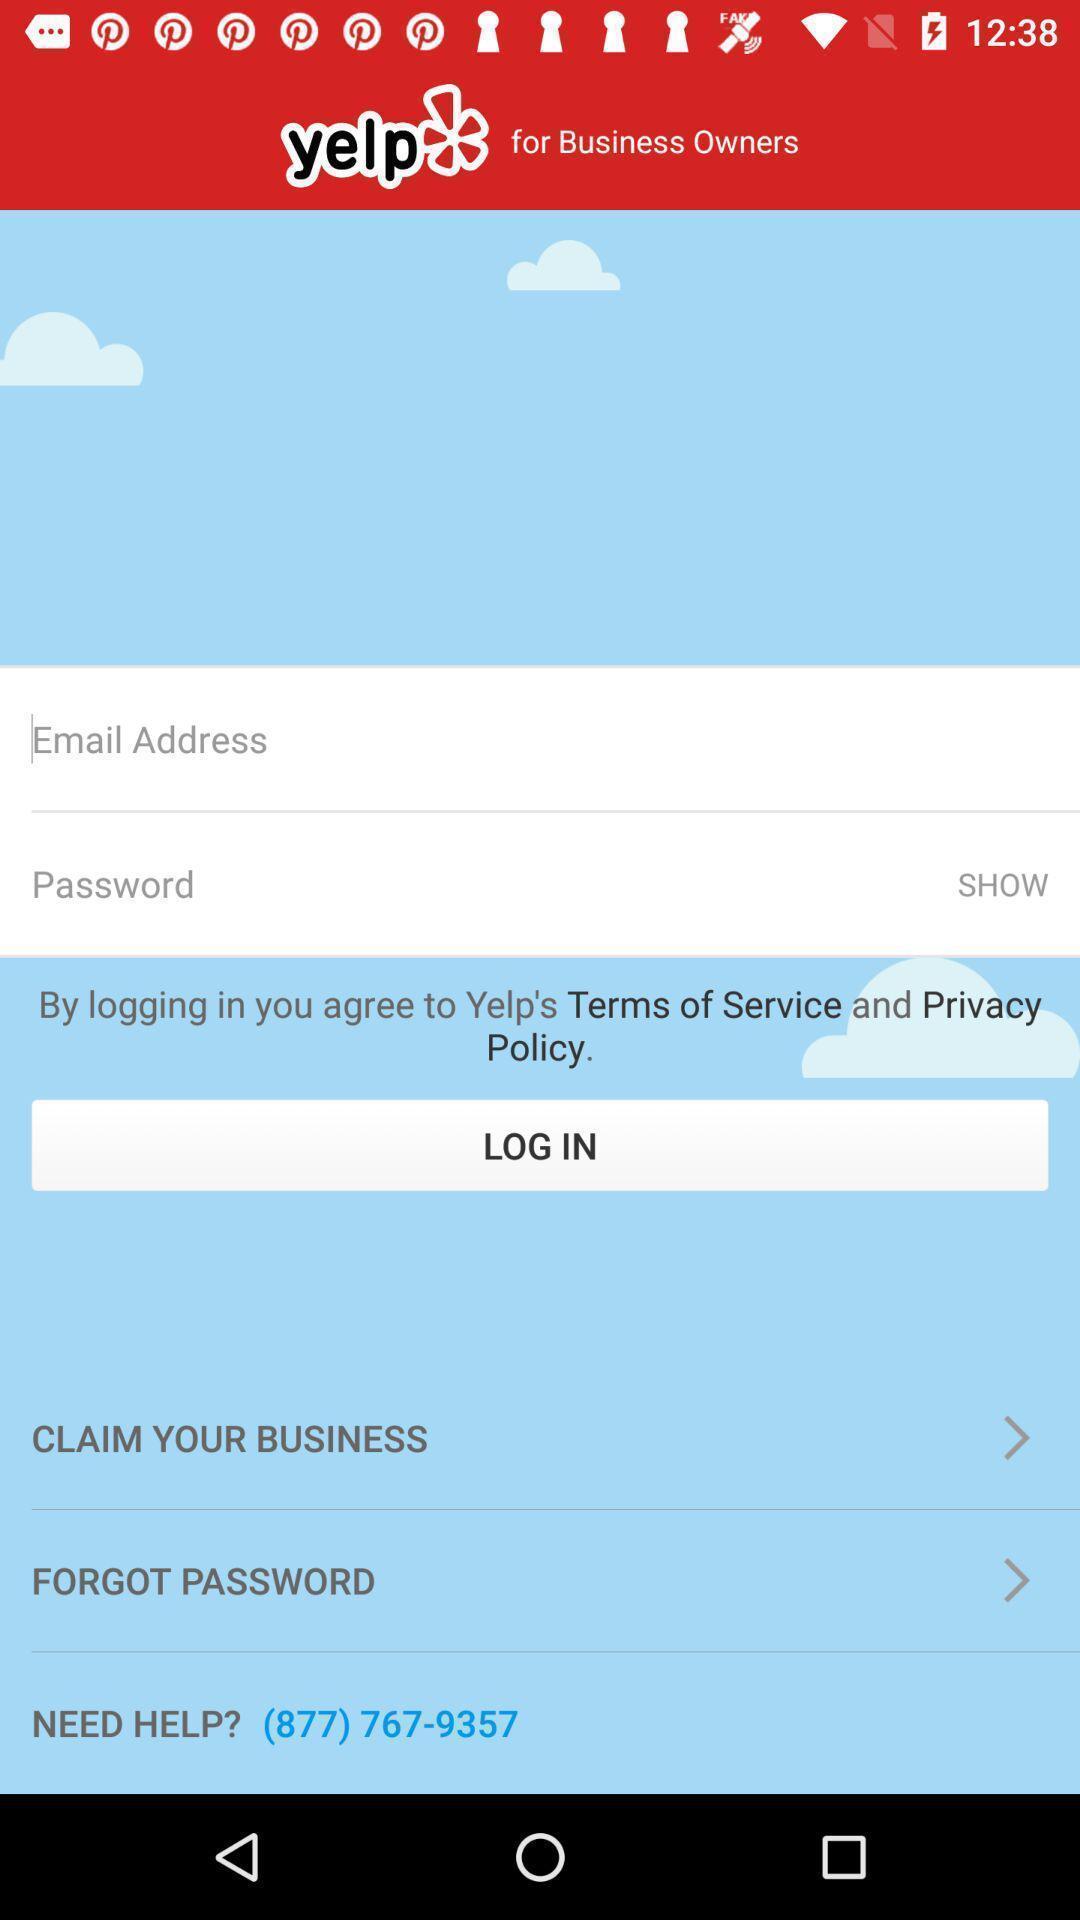Describe the key features of this screenshot. Welcome and log-in page for an application. 